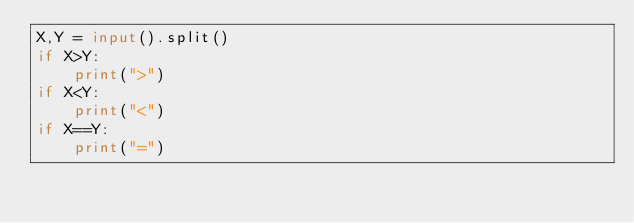Convert code to text. <code><loc_0><loc_0><loc_500><loc_500><_Python_>X,Y = input().split()
if X>Y:
    print(">")
if X<Y:
    print("<")
if X==Y:
    print("=")
</code> 